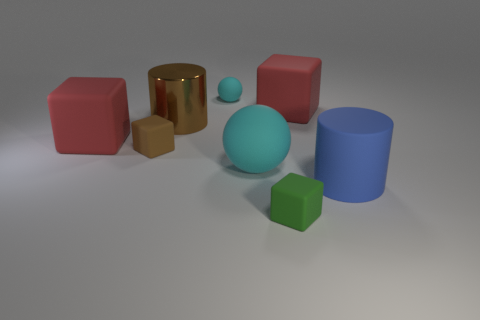What materials are the objects in the image made of, and how does the lighting affect their appearance? The objects display various apparent materials such as matte, shiny, and reflective surfaces. The lighting casts soft shadows and highlights, enhancing the three-dimensional form of each object. The reflective gold and shiny red objects reflect some of the environment, emphasizing their smooth surfaces. 